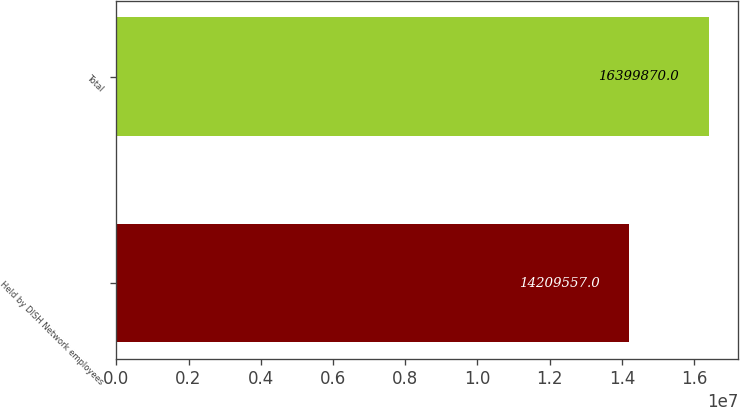Convert chart. <chart><loc_0><loc_0><loc_500><loc_500><bar_chart><fcel>Held by DISH Network employees<fcel>Total<nl><fcel>1.42096e+07<fcel>1.63999e+07<nl></chart> 